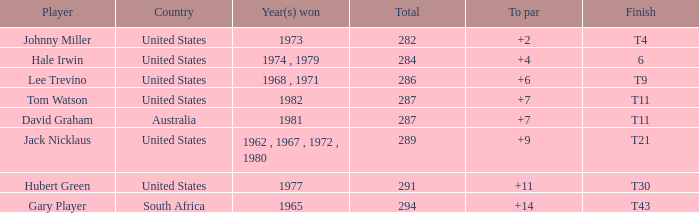What is the combined total of a to par for hubert green and a number exceeding 291? 0.0. Can you give me this table as a dict? {'header': ['Player', 'Country', 'Year(s) won', 'Total', 'To par', 'Finish'], 'rows': [['Johnny Miller', 'United States', '1973', '282', '+2', 'T4'], ['Hale Irwin', 'United States', '1974 , 1979', '284', '+4', '6'], ['Lee Trevino', 'United States', '1968 , 1971', '286', '+6', 'T9'], ['Tom Watson', 'United States', '1982', '287', '+7', 'T11'], ['David Graham', 'Australia', '1981', '287', '+7', 'T11'], ['Jack Nicklaus', 'United States', '1962 , 1967 , 1972 , 1980', '289', '+9', 'T21'], ['Hubert Green', 'United States', '1977', '291', '+11', 'T30'], ['Gary Player', 'South Africa', '1965', '294', '+14', 'T43']]} 